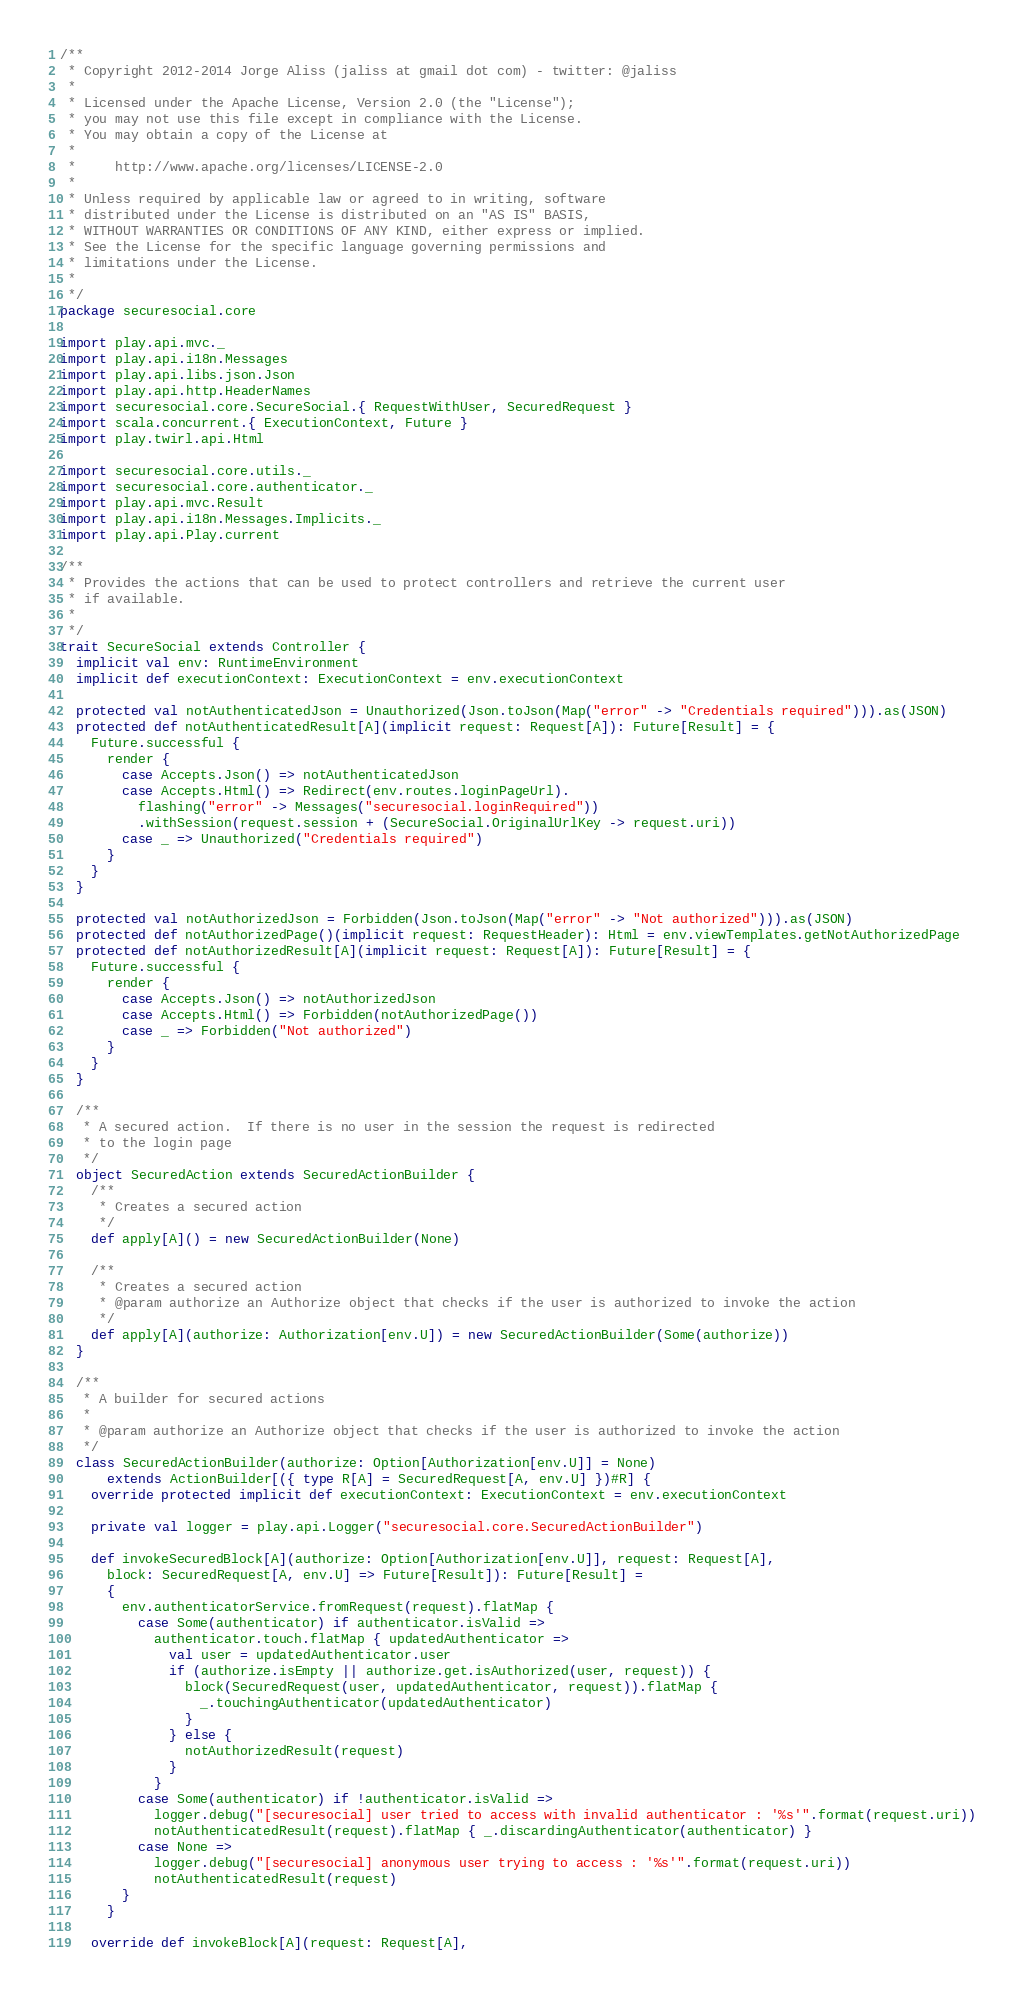Convert code to text. <code><loc_0><loc_0><loc_500><loc_500><_Scala_>/**
 * Copyright 2012-2014 Jorge Aliss (jaliss at gmail dot com) - twitter: @jaliss
 *
 * Licensed under the Apache License, Version 2.0 (the "License");
 * you may not use this file except in compliance with the License.
 * You may obtain a copy of the License at
 *
 *     http://www.apache.org/licenses/LICENSE-2.0
 *
 * Unless required by applicable law or agreed to in writing, software
 * distributed under the License is distributed on an "AS IS" BASIS,
 * WITHOUT WARRANTIES OR CONDITIONS OF ANY KIND, either express or implied.
 * See the License for the specific language governing permissions and
 * limitations under the License.
 *
 */
package securesocial.core

import play.api.mvc._
import play.api.i18n.Messages
import play.api.libs.json.Json
import play.api.http.HeaderNames
import securesocial.core.SecureSocial.{ RequestWithUser, SecuredRequest }
import scala.concurrent.{ ExecutionContext, Future }
import play.twirl.api.Html

import securesocial.core.utils._
import securesocial.core.authenticator._
import play.api.mvc.Result
import play.api.i18n.Messages.Implicits._
import play.api.Play.current

/**
 * Provides the actions that can be used to protect controllers and retrieve the current user
 * if available.
 *
 */
trait SecureSocial extends Controller {
  implicit val env: RuntimeEnvironment
  implicit def executionContext: ExecutionContext = env.executionContext

  protected val notAuthenticatedJson = Unauthorized(Json.toJson(Map("error" -> "Credentials required"))).as(JSON)
  protected def notAuthenticatedResult[A](implicit request: Request[A]): Future[Result] = {
    Future.successful {
      render {
        case Accepts.Json() => notAuthenticatedJson
        case Accepts.Html() => Redirect(env.routes.loginPageUrl).
          flashing("error" -> Messages("securesocial.loginRequired"))
          .withSession(request.session + (SecureSocial.OriginalUrlKey -> request.uri))
        case _ => Unauthorized("Credentials required")
      }
    }
  }

  protected val notAuthorizedJson = Forbidden(Json.toJson(Map("error" -> "Not authorized"))).as(JSON)
  protected def notAuthorizedPage()(implicit request: RequestHeader): Html = env.viewTemplates.getNotAuthorizedPage
  protected def notAuthorizedResult[A](implicit request: Request[A]): Future[Result] = {
    Future.successful {
      render {
        case Accepts.Json() => notAuthorizedJson
        case Accepts.Html() => Forbidden(notAuthorizedPage())
        case _ => Forbidden("Not authorized")
      }
    }
  }

  /**
   * A secured action.  If there is no user in the session the request is redirected
   * to the login page
   */
  object SecuredAction extends SecuredActionBuilder {
    /**
     * Creates a secured action
     */
    def apply[A]() = new SecuredActionBuilder(None)

    /**
     * Creates a secured action
     * @param authorize an Authorize object that checks if the user is authorized to invoke the action
     */
    def apply[A](authorize: Authorization[env.U]) = new SecuredActionBuilder(Some(authorize))
  }

  /**
   * A builder for secured actions
   *
   * @param authorize an Authorize object that checks if the user is authorized to invoke the action
   */
  class SecuredActionBuilder(authorize: Option[Authorization[env.U]] = None)
      extends ActionBuilder[({ type R[A] = SecuredRequest[A, env.U] })#R] {
    override protected implicit def executionContext: ExecutionContext = env.executionContext

    private val logger = play.api.Logger("securesocial.core.SecuredActionBuilder")

    def invokeSecuredBlock[A](authorize: Option[Authorization[env.U]], request: Request[A],
      block: SecuredRequest[A, env.U] => Future[Result]): Future[Result] =
      {
        env.authenticatorService.fromRequest(request).flatMap {
          case Some(authenticator) if authenticator.isValid =>
            authenticator.touch.flatMap { updatedAuthenticator =>
              val user = updatedAuthenticator.user
              if (authorize.isEmpty || authorize.get.isAuthorized(user, request)) {
                block(SecuredRequest(user, updatedAuthenticator, request)).flatMap {
                  _.touchingAuthenticator(updatedAuthenticator)
                }
              } else {
                notAuthorizedResult(request)
              }
            }
          case Some(authenticator) if !authenticator.isValid =>
            logger.debug("[securesocial] user tried to access with invalid authenticator : '%s'".format(request.uri))
            notAuthenticatedResult(request).flatMap { _.discardingAuthenticator(authenticator) }
          case None =>
            logger.debug("[securesocial] anonymous user trying to access : '%s'".format(request.uri))
            notAuthenticatedResult(request)
        }
      }

    override def invokeBlock[A](request: Request[A],</code> 